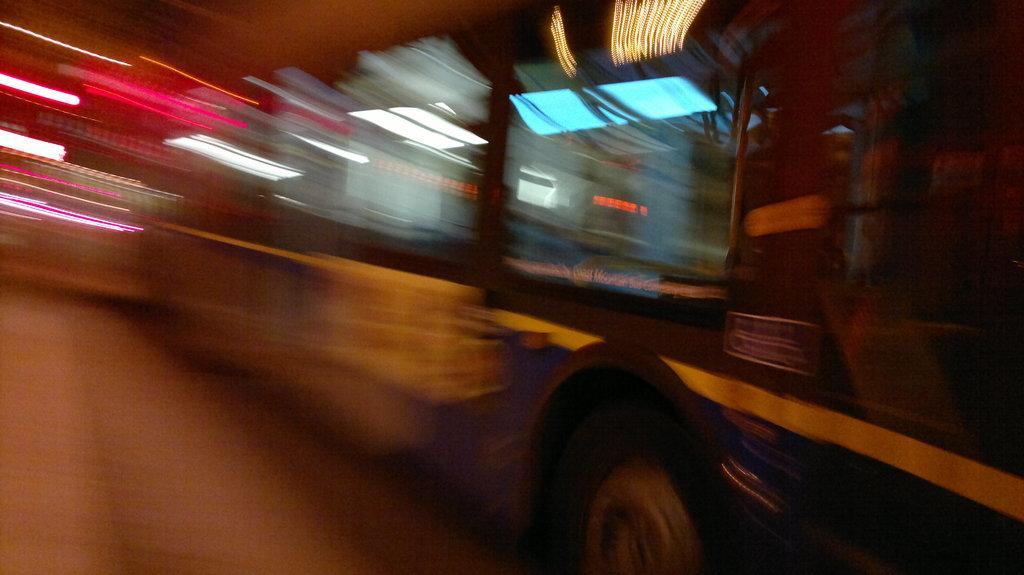What is the main subject of the image? The main subject of the image is a vehicle. How many dimes can be seen on the vehicle in the image? There are no dimes visible on the vehicle in the image. What type of wine is being served in the image? There is no wine present in the image. Can you spot an owl perched on the vehicle in the image? There is no owl present in the image. 